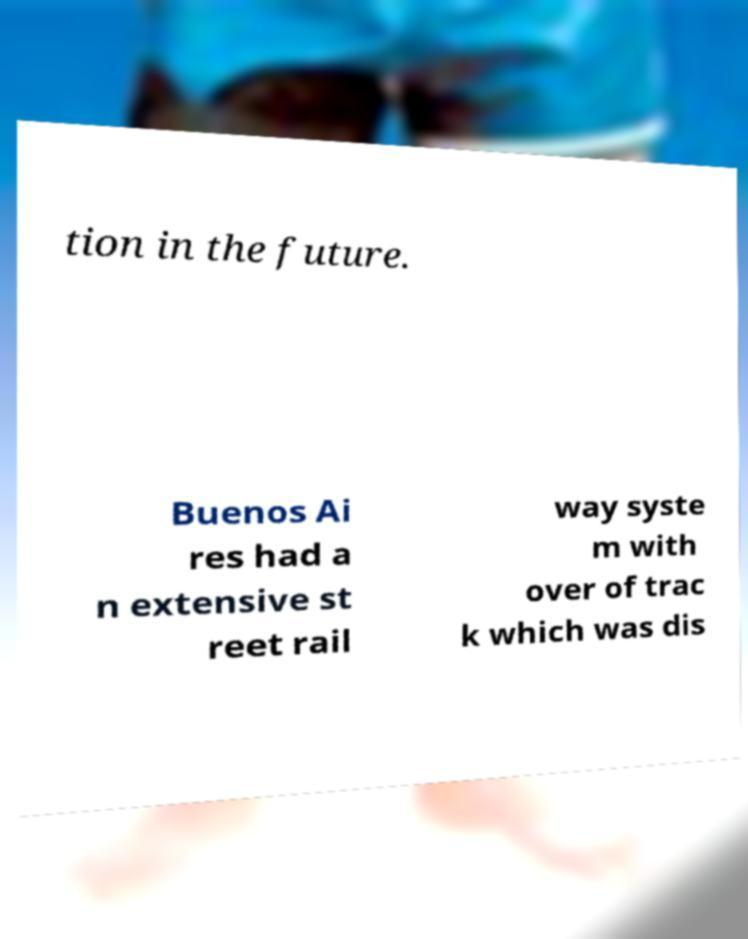Can you accurately transcribe the text from the provided image for me? tion in the future. Buenos Ai res had a n extensive st reet rail way syste m with over of trac k which was dis 